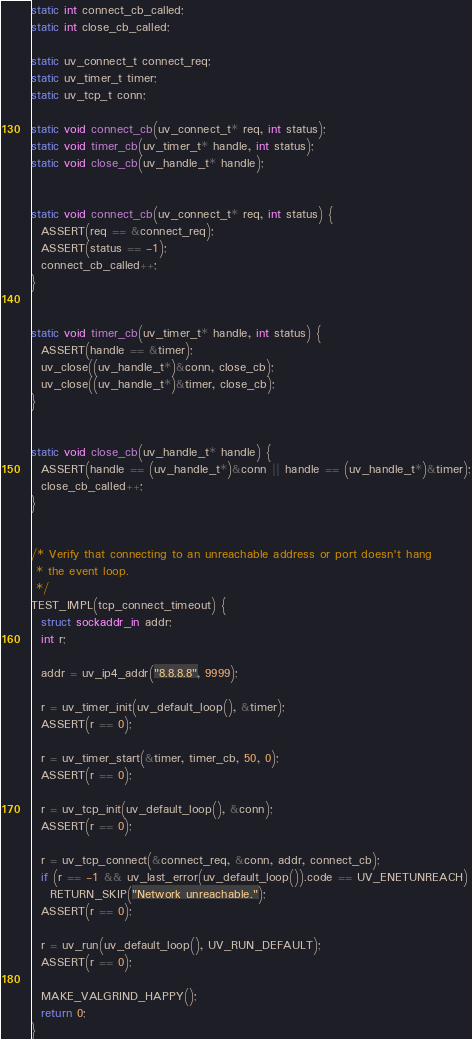<code> <loc_0><loc_0><loc_500><loc_500><_C_>

static int connect_cb_called;
static int close_cb_called;

static uv_connect_t connect_req;
static uv_timer_t timer;
static uv_tcp_t conn;

static void connect_cb(uv_connect_t* req, int status);
static void timer_cb(uv_timer_t* handle, int status);
static void close_cb(uv_handle_t* handle);


static void connect_cb(uv_connect_t* req, int status) {
  ASSERT(req == &connect_req);
  ASSERT(status == -1);
  connect_cb_called++;
}


static void timer_cb(uv_timer_t* handle, int status) {
  ASSERT(handle == &timer);
  uv_close((uv_handle_t*)&conn, close_cb);
  uv_close((uv_handle_t*)&timer, close_cb);
}


static void close_cb(uv_handle_t* handle) {
  ASSERT(handle == (uv_handle_t*)&conn || handle == (uv_handle_t*)&timer);
  close_cb_called++;
}


/* Verify that connecting to an unreachable address or port doesn't hang
 * the event loop.
 */
TEST_IMPL(tcp_connect_timeout) {
  struct sockaddr_in addr;
  int r;

  addr = uv_ip4_addr("8.8.8.8", 9999);

  r = uv_timer_init(uv_default_loop(), &timer);
  ASSERT(r == 0);

  r = uv_timer_start(&timer, timer_cb, 50, 0);
  ASSERT(r == 0);

  r = uv_tcp_init(uv_default_loop(), &conn);
  ASSERT(r == 0);

  r = uv_tcp_connect(&connect_req, &conn, addr, connect_cb);
  if (r == -1 && uv_last_error(uv_default_loop()).code == UV_ENETUNREACH)
    RETURN_SKIP("Network unreachable.");
  ASSERT(r == 0);

  r = uv_run(uv_default_loop(), UV_RUN_DEFAULT);
  ASSERT(r == 0);

  MAKE_VALGRIND_HAPPY();
  return 0;
}
</code> 